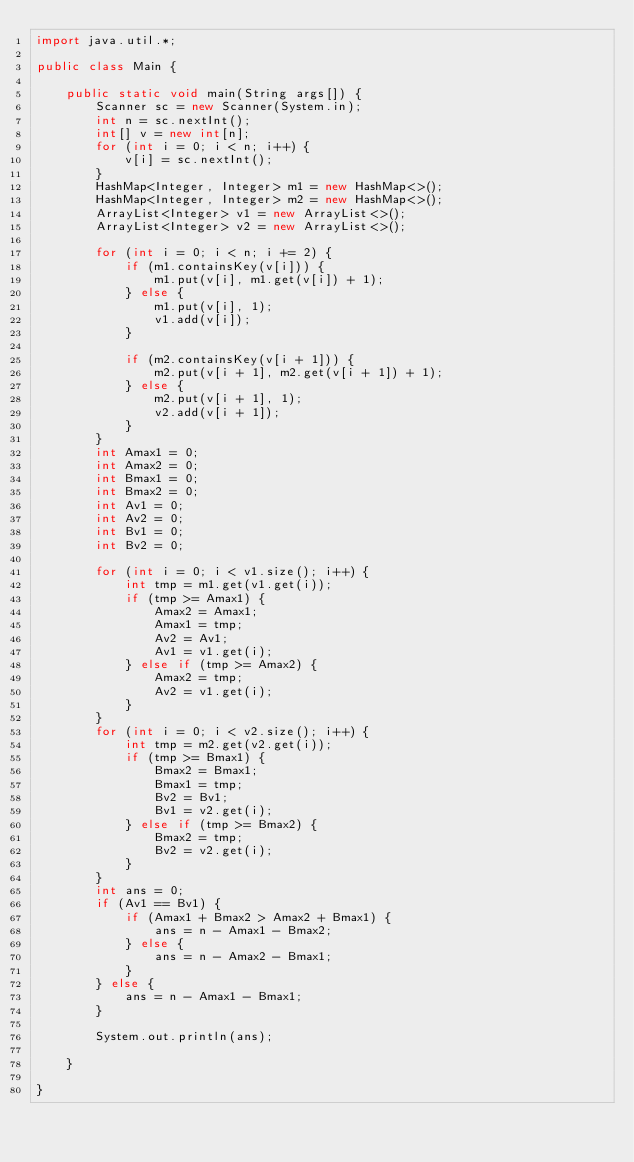Convert code to text. <code><loc_0><loc_0><loc_500><loc_500><_Java_>import java.util.*;

public class Main {

    public static void main(String args[]) {
        Scanner sc = new Scanner(System.in);
        int n = sc.nextInt();
        int[] v = new int[n];
        for (int i = 0; i < n; i++) {
            v[i] = sc.nextInt();
        }
        HashMap<Integer, Integer> m1 = new HashMap<>();
        HashMap<Integer, Integer> m2 = new HashMap<>();
        ArrayList<Integer> v1 = new ArrayList<>();
        ArrayList<Integer> v2 = new ArrayList<>();

        for (int i = 0; i < n; i += 2) {
            if (m1.containsKey(v[i])) {
                m1.put(v[i], m1.get(v[i]) + 1);
            } else {
                m1.put(v[i], 1);
                v1.add(v[i]);
            }

            if (m2.containsKey(v[i + 1])) {
                m2.put(v[i + 1], m2.get(v[i + 1]) + 1);
            } else {
                m2.put(v[i + 1], 1);
                v2.add(v[i + 1]);
            }
        }
        int Amax1 = 0;
        int Amax2 = 0;
        int Bmax1 = 0;
        int Bmax2 = 0;
        int Av1 = 0;
        int Av2 = 0;
        int Bv1 = 0;
        int Bv2 = 0;

        for (int i = 0; i < v1.size(); i++) {
            int tmp = m1.get(v1.get(i));
            if (tmp >= Amax1) {
                Amax2 = Amax1;
                Amax1 = tmp;
                Av2 = Av1;
                Av1 = v1.get(i);
            } else if (tmp >= Amax2) {
                Amax2 = tmp;
                Av2 = v1.get(i);
            }
        }
        for (int i = 0; i < v2.size(); i++) {
            int tmp = m2.get(v2.get(i));
            if (tmp >= Bmax1) {
                Bmax2 = Bmax1;
                Bmax1 = tmp;
                Bv2 = Bv1;
                Bv1 = v2.get(i);
            } else if (tmp >= Bmax2) {
                Bmax2 = tmp;
                Bv2 = v2.get(i);
            }
        }
        int ans = 0;
        if (Av1 == Bv1) {
            if (Amax1 + Bmax2 > Amax2 + Bmax1) {
                ans = n - Amax1 - Bmax2;
            } else {
                ans = n - Amax2 - Bmax1;
            }
        } else {
            ans = n - Amax1 - Bmax1;
        }

        System.out.println(ans);

    }

}
</code> 